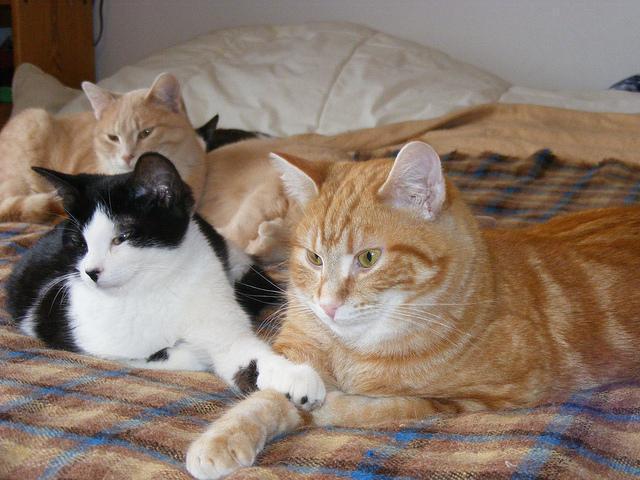How many cats are in this picture?
Give a very brief answer. 3. How many cats?
Give a very brief answer. 3. How many cats are in the picture?
Give a very brief answer. 3. 